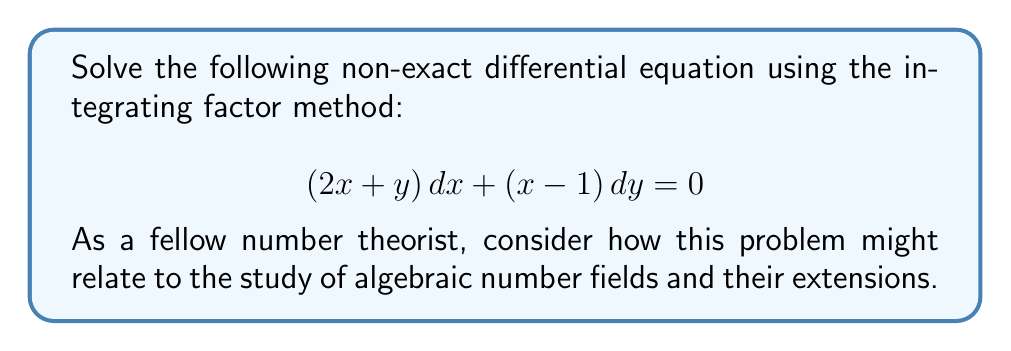Help me with this question. Let's solve this step-by-step using the integrating factor method:

1) First, we need to check if the equation is exact. For an exact equation, we should have:

   $$\frac{\partial M}{\partial y} = \frac{\partial N}{\partial x}$$

   Here, $M = 2x + y$ and $N = x - 1$

   $$\frac{\partial M}{\partial y} = 1 \neq 1 = \frac{\partial N}{\partial x}$$

   So, the equation is not exact.

2) To find the integrating factor, we use the formula:

   $$\mu = e^{\int \frac{1}{N}(\frac{\partial N}{\partial x} - \frac{\partial M}{\partial y})dy}$$

3) Calculating the components:

   $$\frac{\partial N}{\partial x} - \frac{\partial M}{\partial y} = 1 - 1 = 0$$

4) Therefore, our integrating factor is:

   $$\mu = e^{\int 0 dy} = e^0 = 1$$

5) Multiply the original equation by the integrating factor:

   $$(2x + y)\,dx + (x - 1)\,dy = 0$$

6) Now, we can treat this as an exact equation. Let's find a function $F(x,y)$ such that:

   $$\frac{\partial F}{\partial x} = 2x + y \quad \text{and} \quad \frac{\partial F}{\partial y} = x - 1$$

7) Integrating the first equation with respect to x:

   $$F(x,y) = x^2 + xy + g(y)$$

8) Differentiating with respect to y:

   $$\frac{\partial F}{\partial y} = x + g'(y) = x - 1$$

9) Therefore, $g'(y) = -1$, so $g(y) = -y + C$

10) Our general solution is:

    $$F(x,y) = x^2 + xy - y + C = 0$$

11) Rearranging:

    $$x^2 + xy - y = C$$

This is our final solution.
Answer: The general solution to the differential equation is:

$$x^2 + xy - y = C$$

where $C$ is an arbitrary constant. 